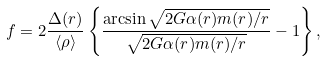<formula> <loc_0><loc_0><loc_500><loc_500>f = 2 \frac { \Delta ( r ) } { \langle \rho \rangle } \left \{ \frac { \arcsin \sqrt { 2 G \alpha ( r ) m ( r ) / r } } { \sqrt { 2 G \alpha ( r ) m ( r ) / r } } - 1 \right \} ,</formula> 